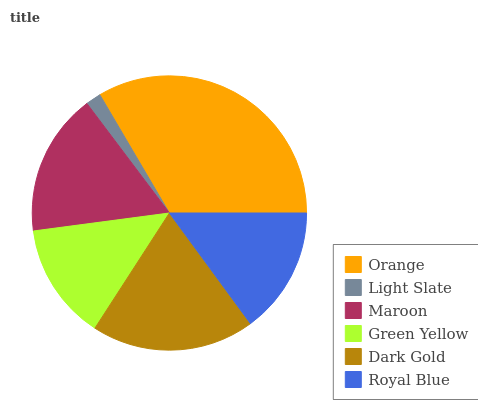Is Light Slate the minimum?
Answer yes or no. Yes. Is Orange the maximum?
Answer yes or no. Yes. Is Maroon the minimum?
Answer yes or no. No. Is Maroon the maximum?
Answer yes or no. No. Is Maroon greater than Light Slate?
Answer yes or no. Yes. Is Light Slate less than Maroon?
Answer yes or no. Yes. Is Light Slate greater than Maroon?
Answer yes or no. No. Is Maroon less than Light Slate?
Answer yes or no. No. Is Maroon the high median?
Answer yes or no. Yes. Is Royal Blue the low median?
Answer yes or no. Yes. Is Orange the high median?
Answer yes or no. No. Is Maroon the low median?
Answer yes or no. No. 